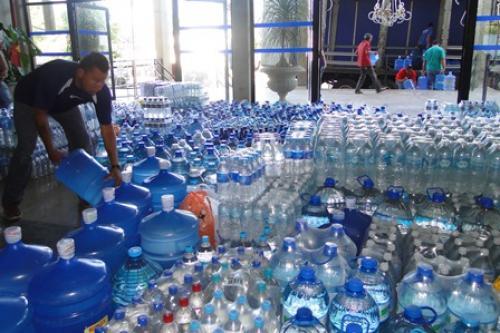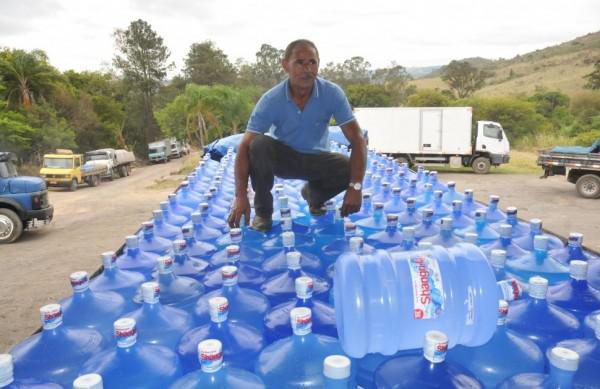The first image is the image on the left, the second image is the image on the right. Analyze the images presented: Is the assertion "The left image contains no more than one upright water jug, and the right image includes only upright jugs with blue caps." valid? Answer yes or no. No. The first image is the image on the left, the second image is the image on the right. Examine the images to the left and right. Is the description "There are less than three bottles in the left image." accurate? Answer yes or no. No. 